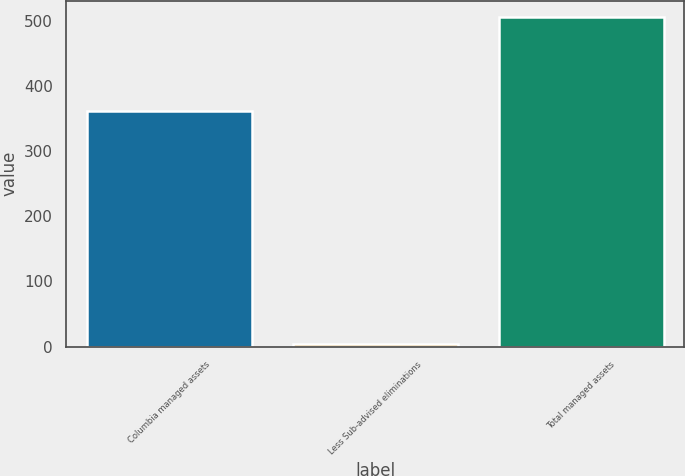<chart> <loc_0><loc_0><loc_500><loc_500><bar_chart><fcel>Columbia managed assets<fcel>Less Sub-advised eliminations<fcel>Total managed assets<nl><fcel>361.2<fcel>3.5<fcel>505.6<nl></chart> 